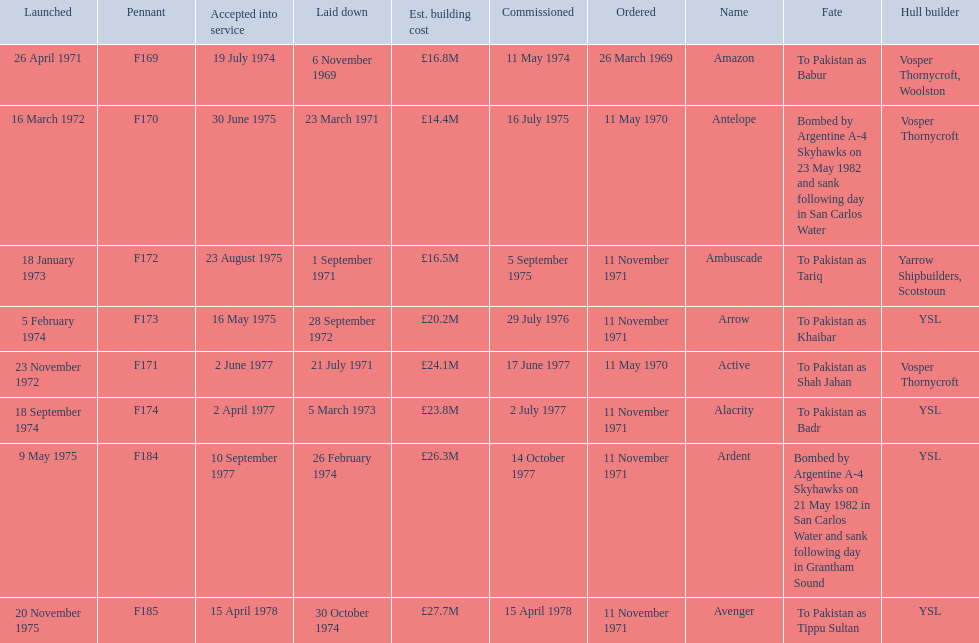What were the estimated building costs of the frigates? £16.8M, £14.4M, £16.5M, £20.2M, £24.1M, £23.8M, £26.3M, £27.7M. Which of these is the largest? £27.7M. Can you give me this table as a dict? {'header': ['Launched', 'Pennant', 'Accepted into service', 'Laid down', 'Est. building cost', 'Commissioned', 'Ordered', 'Name', 'Fate', 'Hull builder'], 'rows': [['26 April 1971', 'F169', '19 July 1974', '6 November 1969', '£16.8M', '11 May 1974', '26 March 1969', 'Amazon', 'To Pakistan as Babur', 'Vosper Thornycroft, Woolston'], ['16 March 1972', 'F170', '30 June 1975', '23 March 1971', '£14.4M', '16 July 1975', '11 May 1970', 'Antelope', 'Bombed by Argentine A-4 Skyhawks on 23 May 1982 and sank following day in San Carlos Water', 'Vosper Thornycroft'], ['18 January 1973', 'F172', '23 August 1975', '1 September 1971', '£16.5M', '5 September 1975', '11 November 1971', 'Ambuscade', 'To Pakistan as Tariq', 'Yarrow Shipbuilders, Scotstoun'], ['5 February 1974', 'F173', '16 May 1975', '28 September 1972', '£20.2M', '29 July 1976', '11 November 1971', 'Arrow', 'To Pakistan as Khaibar', 'YSL'], ['23 November 1972', 'F171', '2 June 1977', '21 July 1971', '£24.1M', '17 June 1977', '11 May 1970', 'Active', 'To Pakistan as Shah Jahan', 'Vosper Thornycroft'], ['18 September 1974', 'F174', '2 April 1977', '5 March 1973', '£23.8M', '2 July 1977', '11 November 1971', 'Alacrity', 'To Pakistan as Badr', 'YSL'], ['9 May 1975', 'F184', '10 September 1977', '26 February 1974', '£26.3M', '14 October 1977', '11 November 1971', 'Ardent', 'Bombed by Argentine A-4 Skyhawks on 21 May 1982 in San Carlos Water and sank following day in Grantham Sound', 'YSL'], ['20 November 1975', 'F185', '15 April 1978', '30 October 1974', '£27.7M', '15 April 1978', '11 November 1971', 'Avenger', 'To Pakistan as Tippu Sultan', 'YSL']]} What ship name does that correspond to? Avenger. 